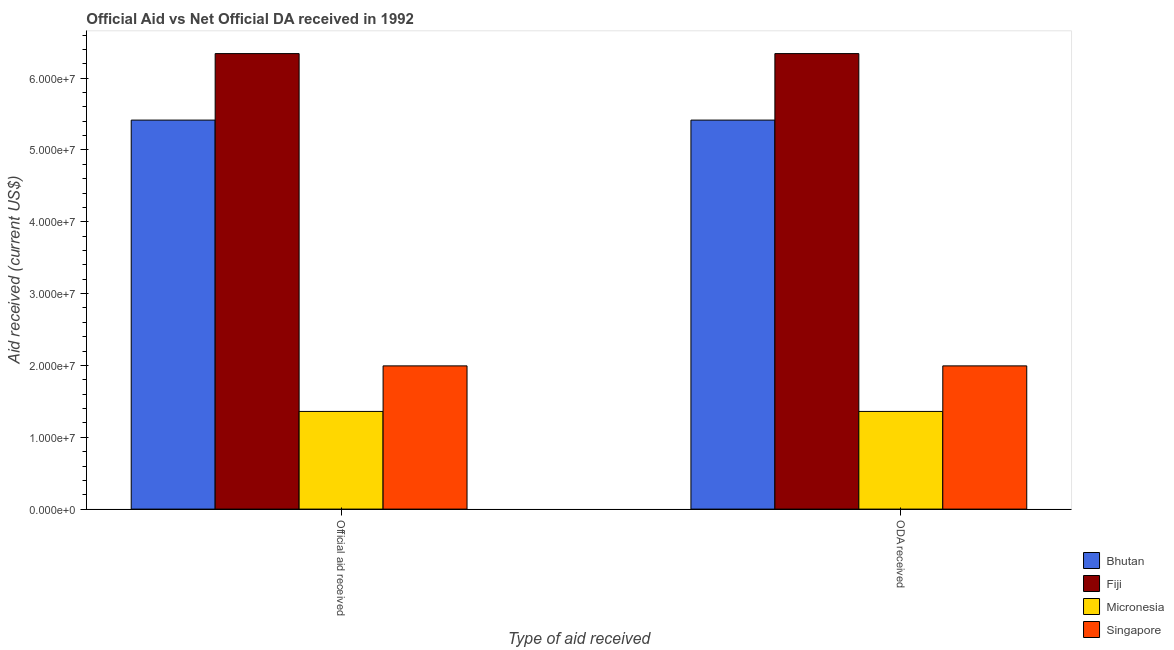How many different coloured bars are there?
Your response must be concise. 4. How many bars are there on the 1st tick from the left?
Offer a terse response. 4. How many bars are there on the 1st tick from the right?
Offer a very short reply. 4. What is the label of the 1st group of bars from the left?
Make the answer very short. Official aid received. What is the official aid received in Fiji?
Your response must be concise. 6.34e+07. Across all countries, what is the maximum official aid received?
Offer a terse response. 6.34e+07. Across all countries, what is the minimum official aid received?
Make the answer very short. 1.36e+07. In which country was the official aid received maximum?
Ensure brevity in your answer.  Fiji. In which country was the official aid received minimum?
Your answer should be very brief. Micronesia. What is the total oda received in the graph?
Ensure brevity in your answer.  1.51e+08. What is the difference between the official aid received in Singapore and that in Bhutan?
Your answer should be very brief. -3.42e+07. What is the difference between the oda received in Singapore and the official aid received in Fiji?
Your answer should be compact. -4.35e+07. What is the average official aid received per country?
Provide a short and direct response. 3.78e+07. What is the ratio of the official aid received in Bhutan to that in Fiji?
Your response must be concise. 0.85. In how many countries, is the oda received greater than the average oda received taken over all countries?
Keep it short and to the point. 2. What does the 4th bar from the left in Official aid received represents?
Make the answer very short. Singapore. What does the 4th bar from the right in ODA received represents?
Your answer should be compact. Bhutan. Are all the bars in the graph horizontal?
Provide a succinct answer. No. How many countries are there in the graph?
Provide a succinct answer. 4. What is the difference between two consecutive major ticks on the Y-axis?
Provide a short and direct response. 1.00e+07. Are the values on the major ticks of Y-axis written in scientific E-notation?
Ensure brevity in your answer.  Yes. Does the graph contain any zero values?
Provide a succinct answer. No. Does the graph contain grids?
Provide a short and direct response. No. How are the legend labels stacked?
Offer a terse response. Vertical. What is the title of the graph?
Your response must be concise. Official Aid vs Net Official DA received in 1992 . What is the label or title of the X-axis?
Give a very brief answer. Type of aid received. What is the label or title of the Y-axis?
Your answer should be compact. Aid received (current US$). What is the Aid received (current US$) in Bhutan in Official aid received?
Make the answer very short. 5.42e+07. What is the Aid received (current US$) in Fiji in Official aid received?
Provide a short and direct response. 6.34e+07. What is the Aid received (current US$) in Micronesia in Official aid received?
Provide a succinct answer. 1.36e+07. What is the Aid received (current US$) in Singapore in Official aid received?
Your answer should be very brief. 1.99e+07. What is the Aid received (current US$) in Bhutan in ODA received?
Offer a very short reply. 5.42e+07. What is the Aid received (current US$) of Fiji in ODA received?
Keep it short and to the point. 6.34e+07. What is the Aid received (current US$) of Micronesia in ODA received?
Provide a short and direct response. 1.36e+07. What is the Aid received (current US$) in Singapore in ODA received?
Your answer should be compact. 1.99e+07. Across all Type of aid received, what is the maximum Aid received (current US$) in Bhutan?
Keep it short and to the point. 5.42e+07. Across all Type of aid received, what is the maximum Aid received (current US$) in Fiji?
Ensure brevity in your answer.  6.34e+07. Across all Type of aid received, what is the maximum Aid received (current US$) in Micronesia?
Give a very brief answer. 1.36e+07. Across all Type of aid received, what is the maximum Aid received (current US$) of Singapore?
Offer a very short reply. 1.99e+07. Across all Type of aid received, what is the minimum Aid received (current US$) in Bhutan?
Keep it short and to the point. 5.42e+07. Across all Type of aid received, what is the minimum Aid received (current US$) in Fiji?
Your response must be concise. 6.34e+07. Across all Type of aid received, what is the minimum Aid received (current US$) of Micronesia?
Your answer should be compact. 1.36e+07. Across all Type of aid received, what is the minimum Aid received (current US$) of Singapore?
Keep it short and to the point. 1.99e+07. What is the total Aid received (current US$) of Bhutan in the graph?
Ensure brevity in your answer.  1.08e+08. What is the total Aid received (current US$) in Fiji in the graph?
Give a very brief answer. 1.27e+08. What is the total Aid received (current US$) in Micronesia in the graph?
Your answer should be very brief. 2.72e+07. What is the total Aid received (current US$) of Singapore in the graph?
Provide a short and direct response. 3.99e+07. What is the difference between the Aid received (current US$) in Bhutan in Official aid received and that in ODA received?
Offer a very short reply. 0. What is the difference between the Aid received (current US$) of Fiji in Official aid received and that in ODA received?
Provide a short and direct response. 0. What is the difference between the Aid received (current US$) in Micronesia in Official aid received and that in ODA received?
Ensure brevity in your answer.  0. What is the difference between the Aid received (current US$) of Singapore in Official aid received and that in ODA received?
Make the answer very short. 0. What is the difference between the Aid received (current US$) in Bhutan in Official aid received and the Aid received (current US$) in Fiji in ODA received?
Make the answer very short. -9.26e+06. What is the difference between the Aid received (current US$) in Bhutan in Official aid received and the Aid received (current US$) in Micronesia in ODA received?
Make the answer very short. 4.06e+07. What is the difference between the Aid received (current US$) in Bhutan in Official aid received and the Aid received (current US$) in Singapore in ODA received?
Provide a short and direct response. 3.42e+07. What is the difference between the Aid received (current US$) in Fiji in Official aid received and the Aid received (current US$) in Micronesia in ODA received?
Offer a very short reply. 4.98e+07. What is the difference between the Aid received (current US$) in Fiji in Official aid received and the Aid received (current US$) in Singapore in ODA received?
Provide a short and direct response. 4.35e+07. What is the difference between the Aid received (current US$) in Micronesia in Official aid received and the Aid received (current US$) in Singapore in ODA received?
Provide a succinct answer. -6.34e+06. What is the average Aid received (current US$) in Bhutan per Type of aid received?
Offer a very short reply. 5.42e+07. What is the average Aid received (current US$) in Fiji per Type of aid received?
Provide a short and direct response. 6.34e+07. What is the average Aid received (current US$) of Micronesia per Type of aid received?
Keep it short and to the point. 1.36e+07. What is the average Aid received (current US$) in Singapore per Type of aid received?
Keep it short and to the point. 1.99e+07. What is the difference between the Aid received (current US$) in Bhutan and Aid received (current US$) in Fiji in Official aid received?
Make the answer very short. -9.26e+06. What is the difference between the Aid received (current US$) of Bhutan and Aid received (current US$) of Micronesia in Official aid received?
Provide a succinct answer. 4.06e+07. What is the difference between the Aid received (current US$) in Bhutan and Aid received (current US$) in Singapore in Official aid received?
Provide a short and direct response. 3.42e+07. What is the difference between the Aid received (current US$) in Fiji and Aid received (current US$) in Micronesia in Official aid received?
Keep it short and to the point. 4.98e+07. What is the difference between the Aid received (current US$) of Fiji and Aid received (current US$) of Singapore in Official aid received?
Your response must be concise. 4.35e+07. What is the difference between the Aid received (current US$) in Micronesia and Aid received (current US$) in Singapore in Official aid received?
Your answer should be compact. -6.34e+06. What is the difference between the Aid received (current US$) of Bhutan and Aid received (current US$) of Fiji in ODA received?
Your answer should be very brief. -9.26e+06. What is the difference between the Aid received (current US$) of Bhutan and Aid received (current US$) of Micronesia in ODA received?
Your answer should be compact. 4.06e+07. What is the difference between the Aid received (current US$) of Bhutan and Aid received (current US$) of Singapore in ODA received?
Your response must be concise. 3.42e+07. What is the difference between the Aid received (current US$) in Fiji and Aid received (current US$) in Micronesia in ODA received?
Your answer should be very brief. 4.98e+07. What is the difference between the Aid received (current US$) in Fiji and Aid received (current US$) in Singapore in ODA received?
Ensure brevity in your answer.  4.35e+07. What is the difference between the Aid received (current US$) in Micronesia and Aid received (current US$) in Singapore in ODA received?
Give a very brief answer. -6.34e+06. What is the ratio of the Aid received (current US$) in Fiji in Official aid received to that in ODA received?
Your answer should be very brief. 1. What is the ratio of the Aid received (current US$) in Micronesia in Official aid received to that in ODA received?
Offer a very short reply. 1. What is the difference between the highest and the second highest Aid received (current US$) of Bhutan?
Make the answer very short. 0. What is the difference between the highest and the second highest Aid received (current US$) in Fiji?
Provide a succinct answer. 0. What is the difference between the highest and the second highest Aid received (current US$) of Singapore?
Offer a very short reply. 0. What is the difference between the highest and the lowest Aid received (current US$) of Micronesia?
Keep it short and to the point. 0. What is the difference between the highest and the lowest Aid received (current US$) in Singapore?
Provide a succinct answer. 0. 